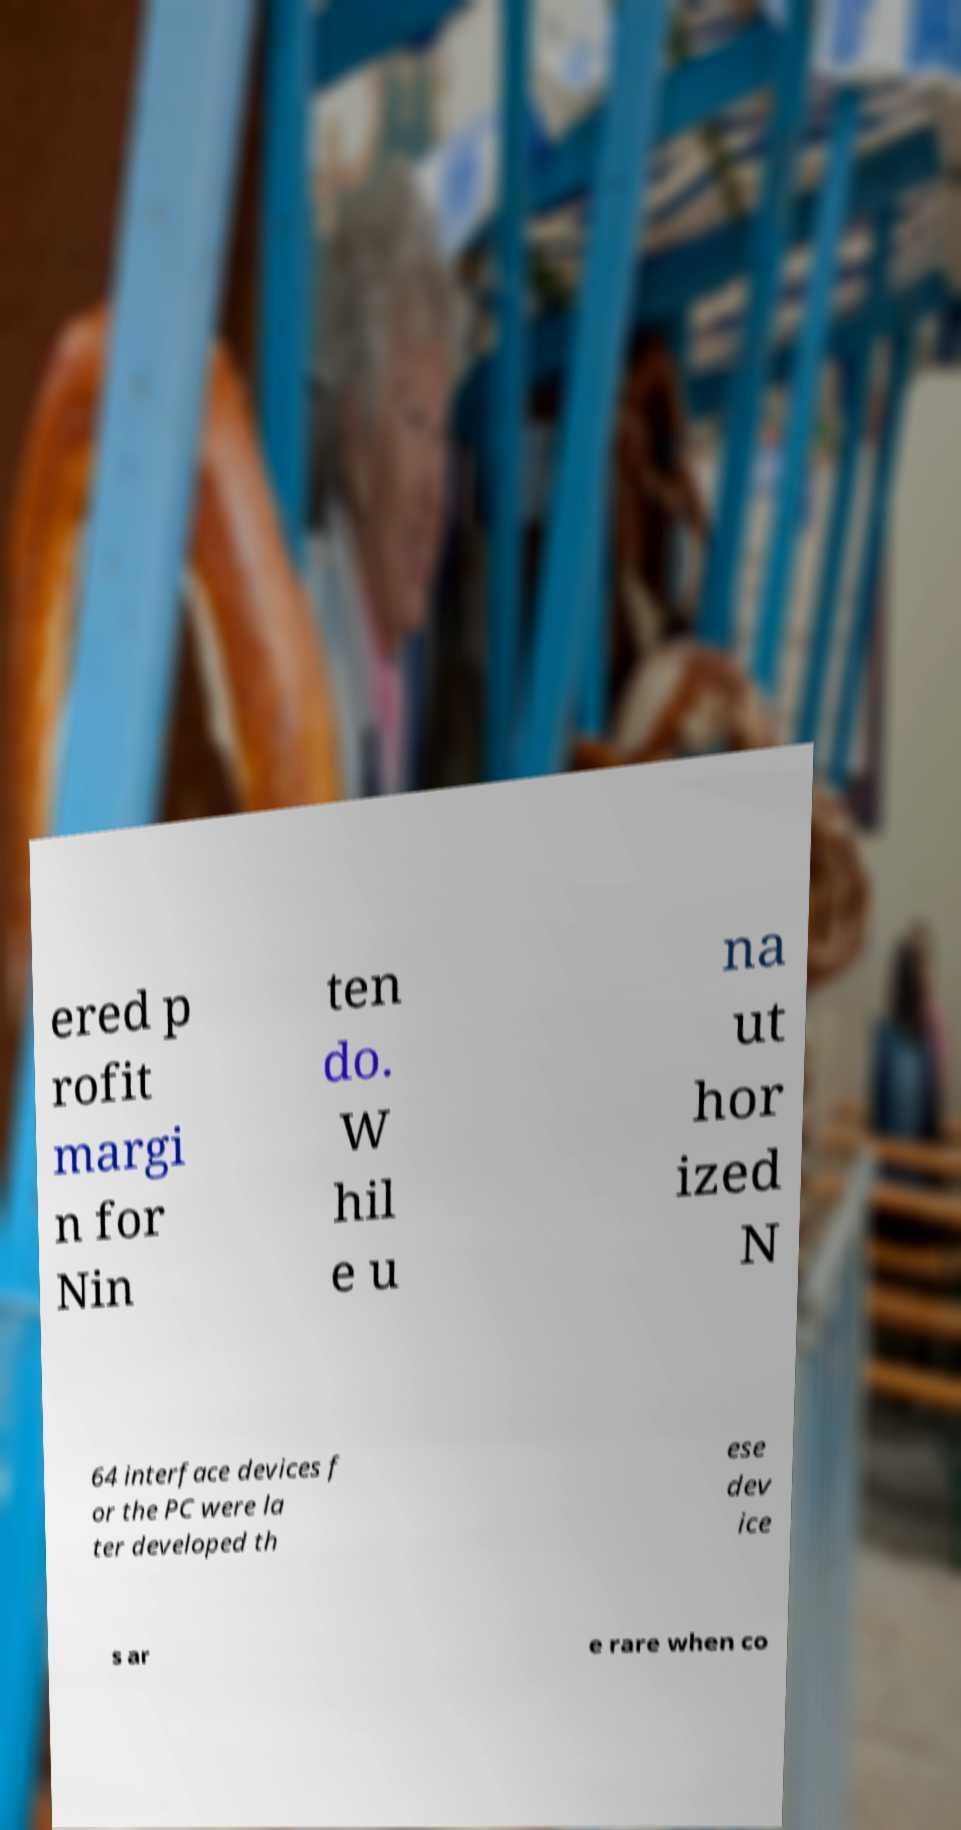There's text embedded in this image that I need extracted. Can you transcribe it verbatim? ered p rofit margi n for Nin ten do. W hil e u na ut hor ized N 64 interface devices f or the PC were la ter developed th ese dev ice s ar e rare when co 